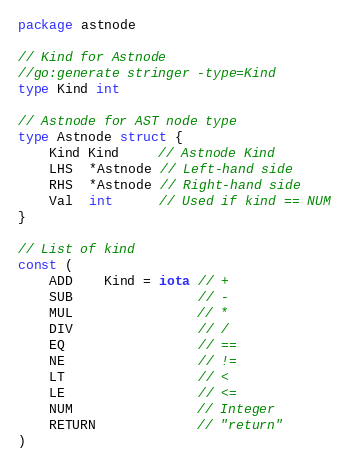<code> <loc_0><loc_0><loc_500><loc_500><_Go_>package astnode

// Kind for Astnode
//go:generate stringer -type=Kind
type Kind int

// Astnode for AST node type
type Astnode struct {
	Kind Kind     // Astnode Kind
	LHS  *Astnode // Left-hand side
	RHS  *Astnode // Right-hand side
	Val  int      // Used if kind == NUM
}

// List of kind
const (
	ADD    Kind = iota // +
	SUB                // -
	MUL                // *
	DIV                // /
	EQ                 // ==
	NE                 // !=
	LT                 // <
	LE                 // <=
	NUM                // Integer
	RETURN             // "return"
)
</code> 